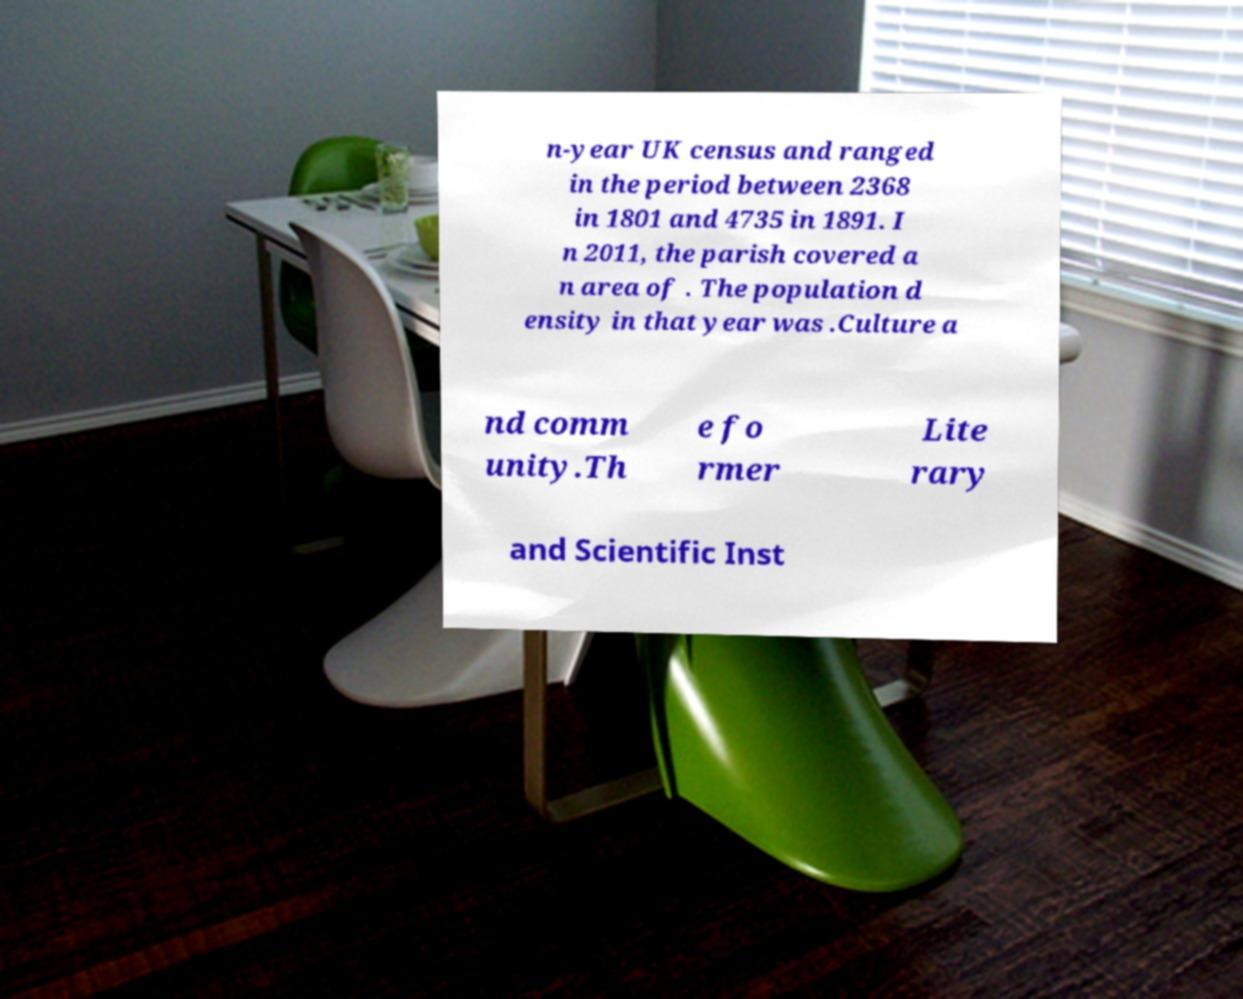Can you read and provide the text displayed in the image?This photo seems to have some interesting text. Can you extract and type it out for me? n-year UK census and ranged in the period between 2368 in 1801 and 4735 in 1891. I n 2011, the parish covered a n area of . The population d ensity in that year was .Culture a nd comm unity.Th e fo rmer Lite rary and Scientific Inst 